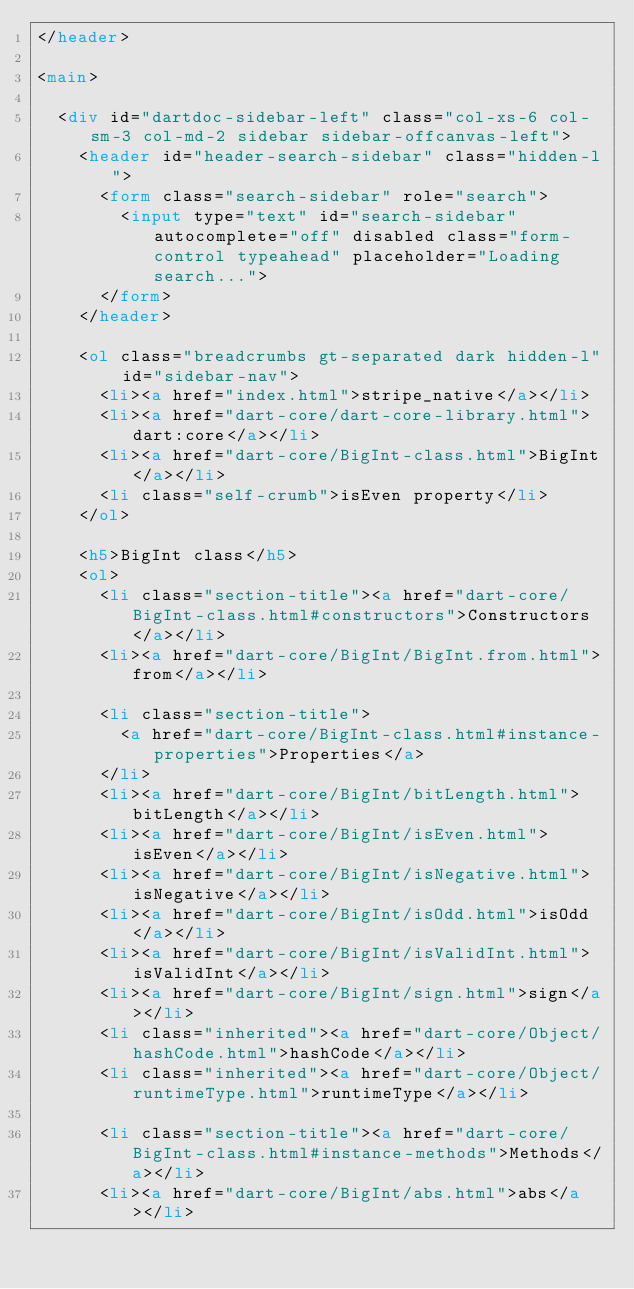Convert code to text. <code><loc_0><loc_0><loc_500><loc_500><_HTML_></header>

<main>

  <div id="dartdoc-sidebar-left" class="col-xs-6 col-sm-3 col-md-2 sidebar sidebar-offcanvas-left">
    <header id="header-search-sidebar" class="hidden-l">
      <form class="search-sidebar" role="search">
        <input type="text" id="search-sidebar" autocomplete="off" disabled class="form-control typeahead" placeholder="Loading search...">
      </form>
    </header>
    
    <ol class="breadcrumbs gt-separated dark hidden-l" id="sidebar-nav">
      <li><a href="index.html">stripe_native</a></li>
      <li><a href="dart-core/dart-core-library.html">dart:core</a></li>
      <li><a href="dart-core/BigInt-class.html">BigInt</a></li>
      <li class="self-crumb">isEven property</li>
    </ol>
    
    <h5>BigInt class</h5>
    <ol>
      <li class="section-title"><a href="dart-core/BigInt-class.html#constructors">Constructors</a></li>
      <li><a href="dart-core/BigInt/BigInt.from.html">from</a></li>
    
      <li class="section-title">
        <a href="dart-core/BigInt-class.html#instance-properties">Properties</a>
      </li>
      <li><a href="dart-core/BigInt/bitLength.html">bitLength</a></li>
      <li><a href="dart-core/BigInt/isEven.html">isEven</a></li>
      <li><a href="dart-core/BigInt/isNegative.html">isNegative</a></li>
      <li><a href="dart-core/BigInt/isOdd.html">isOdd</a></li>
      <li><a href="dart-core/BigInt/isValidInt.html">isValidInt</a></li>
      <li><a href="dart-core/BigInt/sign.html">sign</a></li>
      <li class="inherited"><a href="dart-core/Object/hashCode.html">hashCode</a></li>
      <li class="inherited"><a href="dart-core/Object/runtimeType.html">runtimeType</a></li>
    
      <li class="section-title"><a href="dart-core/BigInt-class.html#instance-methods">Methods</a></li>
      <li><a href="dart-core/BigInt/abs.html">abs</a></li></code> 